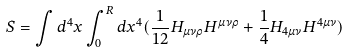<formula> <loc_0><loc_0><loc_500><loc_500>S = \int d ^ { 4 } x \int _ { 0 } ^ { R } d x ^ { 4 } ( \frac { 1 } { 1 2 } H _ { \mu \nu \rho } H ^ { \mu \nu \rho } + \frac { 1 } { 4 } H _ { 4 \mu \nu } H ^ { 4 \mu \nu } )</formula> 